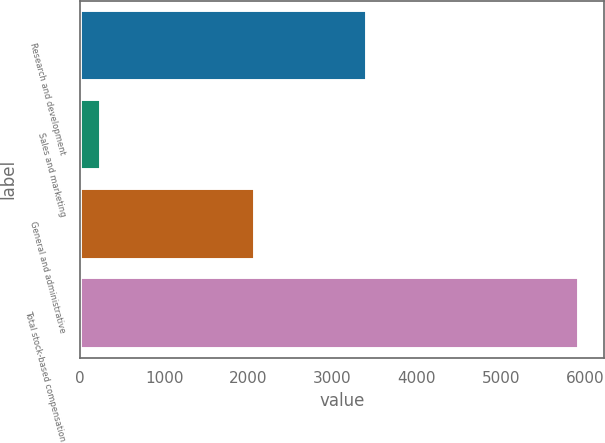<chart> <loc_0><loc_0><loc_500><loc_500><bar_chart><fcel>Research and development<fcel>Sales and marketing<fcel>General and administrative<fcel>Total stock-based compensation<nl><fcel>3409<fcel>249<fcel>2073<fcel>5931<nl></chart> 